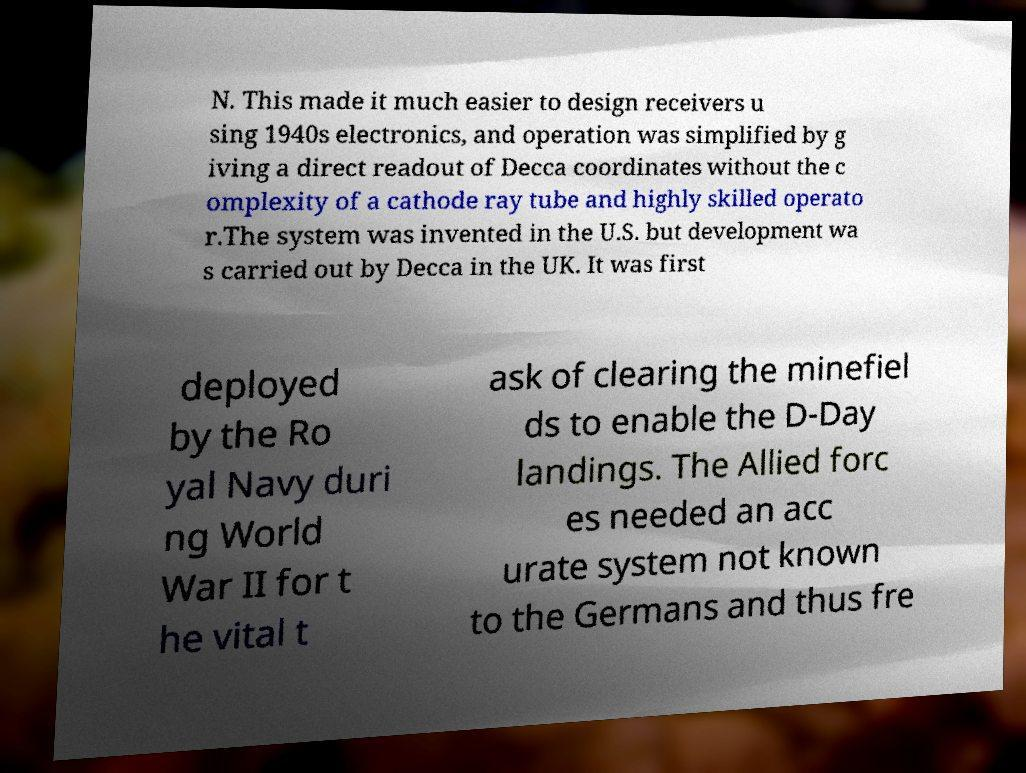For documentation purposes, I need the text within this image transcribed. Could you provide that? N. This made it much easier to design receivers u sing 1940s electronics, and operation was simplified by g iving a direct readout of Decca coordinates without the c omplexity of a cathode ray tube and highly skilled operato r.The system was invented in the U.S. but development wa s carried out by Decca in the UK. It was first deployed by the Ro yal Navy duri ng World War II for t he vital t ask of clearing the minefiel ds to enable the D-Day landings. The Allied forc es needed an acc urate system not known to the Germans and thus fre 